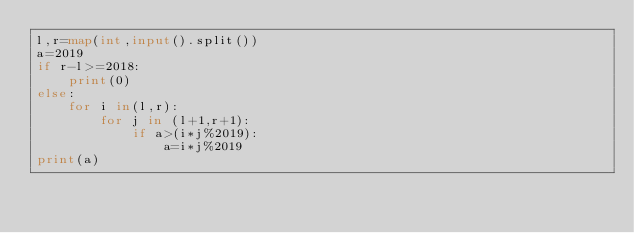<code> <loc_0><loc_0><loc_500><loc_500><_Python_>l,r=map(int,input().split())
a=2019
if r-l>=2018:
    print(0)
else:
    for i in(l,r):
        for j in (l+1,r+1):
            if a>(i*j%2019):
                a=i*j%2019
print(a)</code> 